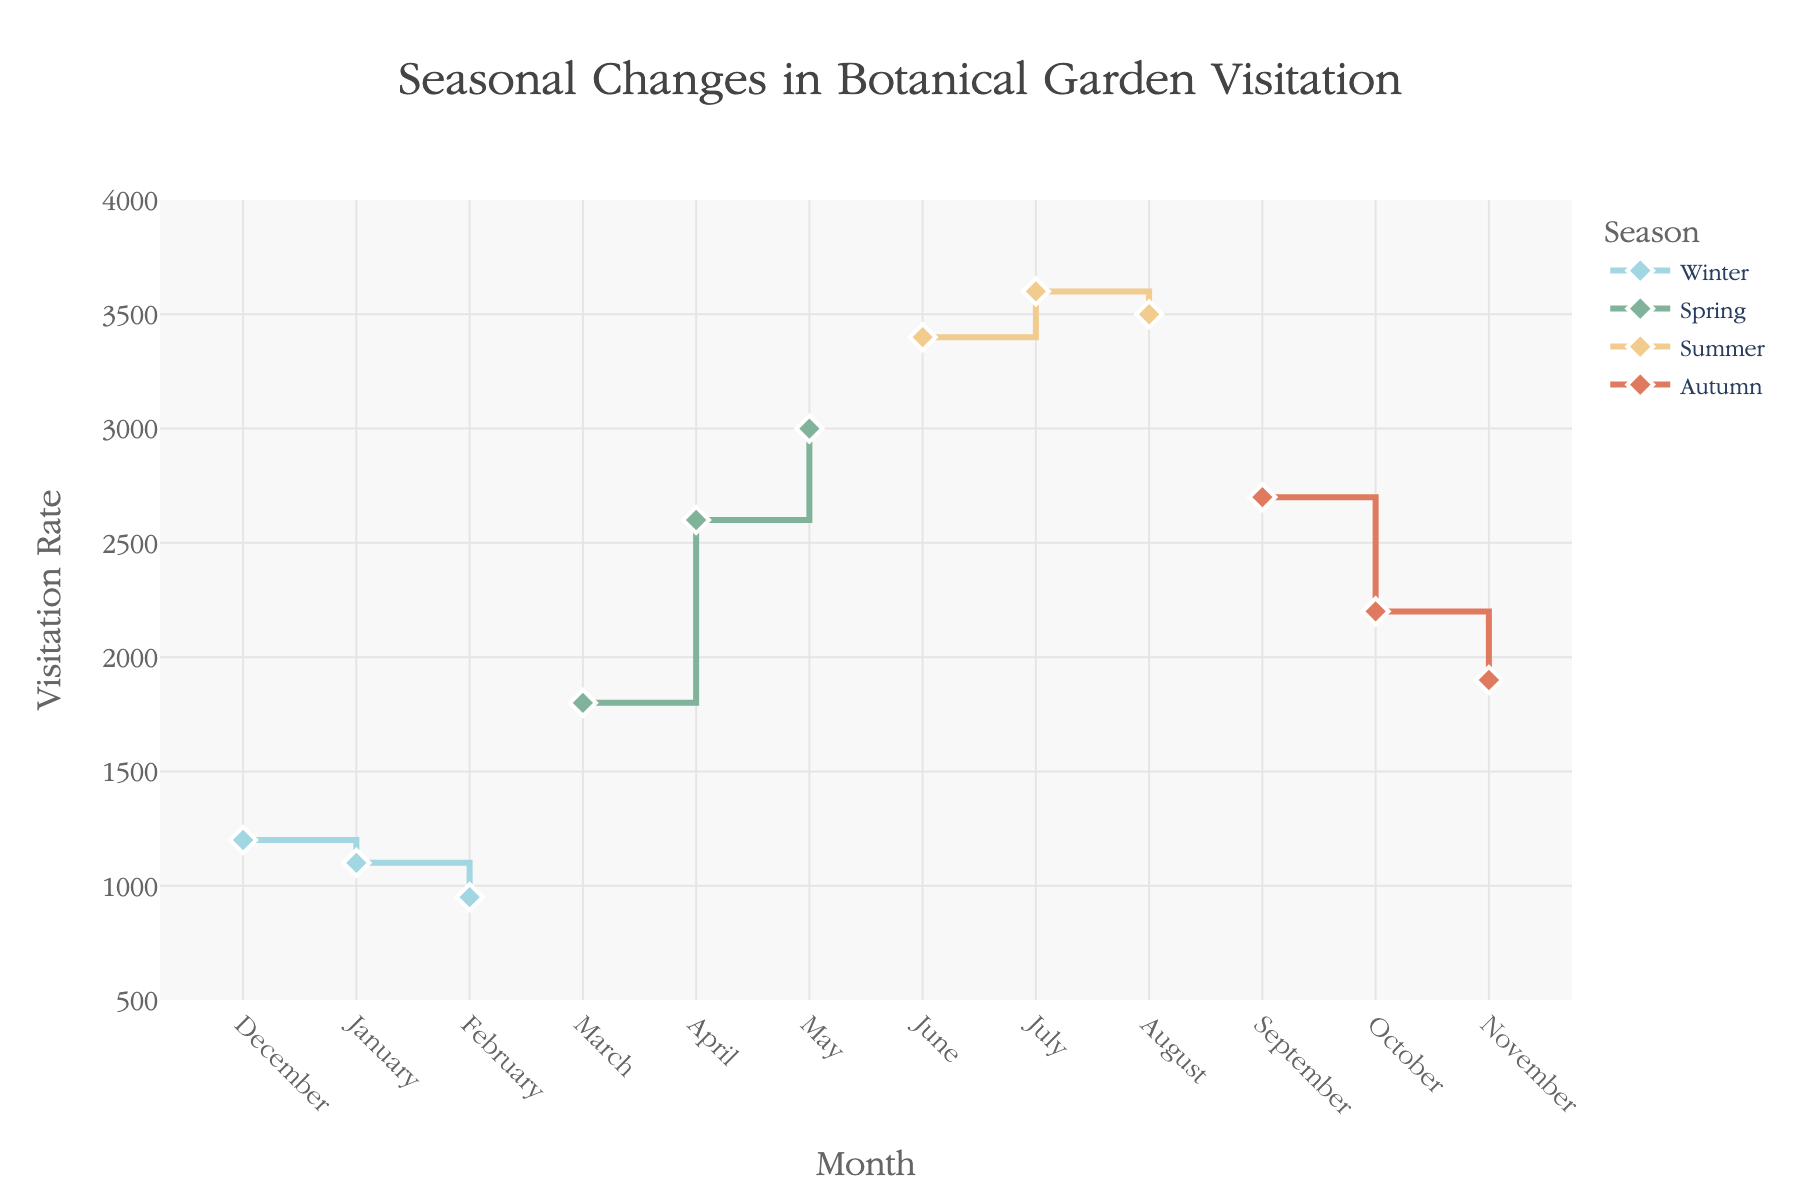Which season has the highest visitation rate in any single month? To find the season with the highest visitation rate, we look for the month with the highest value on the y-axis. The highest rate is 3600 in July, which is part of Summer.
Answer: Summer What is the visitation rate in April? Check the data point corresponding to April. The visitation rate in April is 2600.
Answer: 2600 Which season has the lowest visitation rate in February? February falls in Winter. The visitation rate in February is 950.
Answer: Winter What's the difference in visitation rates between June and July? Locate the visitation rates for June (3400) and July (3600). Calculate the difference: 3600 - 3400 = 200.
Answer: 200 Which month shows the greatest increase in visitation rate compared to the previous month? Compare the rate increase month-by-month. The largest difference is from February to March, increasing from 950 to 1800: 1800 - 950 = 850.
Answer: March What is the total visitation rate for all spring months combined? Sum the rates for March, April, and May: 1800 + 2600 + 3000.
Answer: 7400 During which season do visitation rates consistently increase each month? Look for a season with increasing values month-over-month. Summer shows consistent increases from June to July to August.
Answer: Summer How does the peak value for Winter compare to the lowest value for Summer? The peak for Winter is 1200 (December) and the lowest for Summer is 3400 (June). Compare the two values: 3400 - 1200 = 2200.
Answer: 2200 What is the average visitation rate in Autumn? Average the autumn months’ rates: (2700 + 2200 + 1900) / 3.
Answer: 2267 In which month does the visitation rate drop most sharply? Find the largest decline between successive months. The biggest drop is from August to September: 3500 - 2700 = 800.
Answer: September 